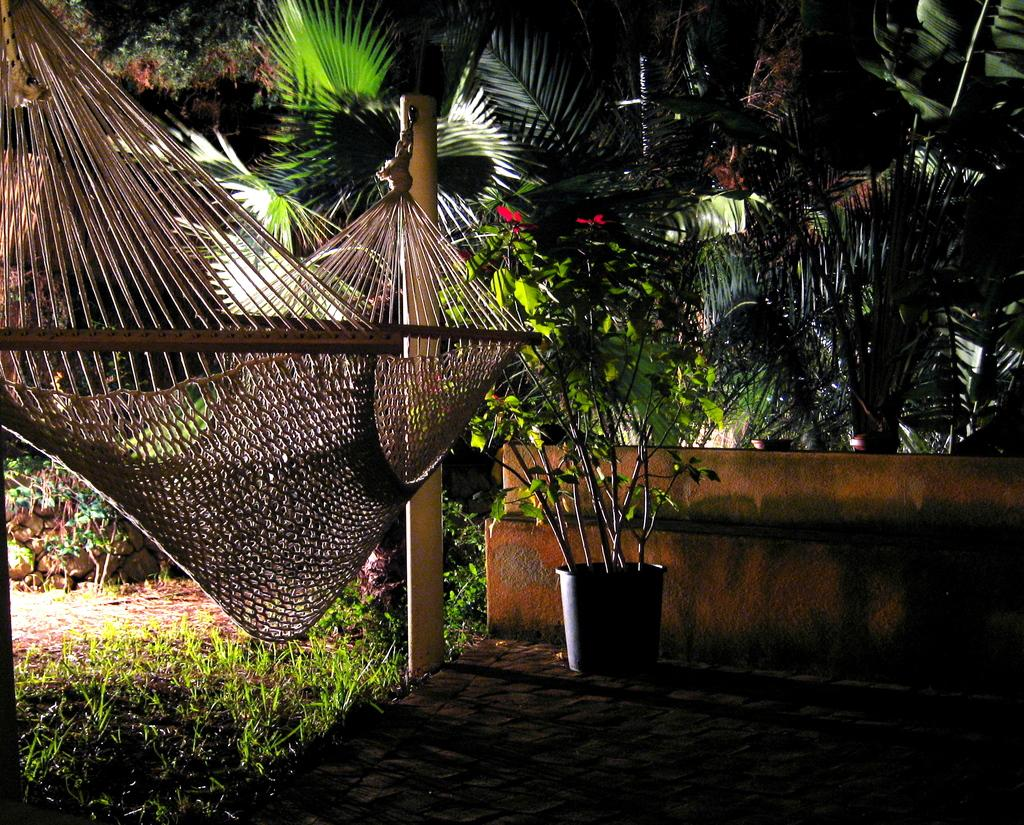Where was the image taken? The image was clicked outside. What type of vegetation can be seen in the image? There are trees and flowers in the image. What objects are present in the image that contain plants? There are flower pots in the image. What is the ground surface like in the image? There is grass at the bottom of the image. How many balls are visible in the image? There are no balls present in the image. What type of farming equipment can be seen in the image? There is no farming equipment, such as a plough, present in the image. 